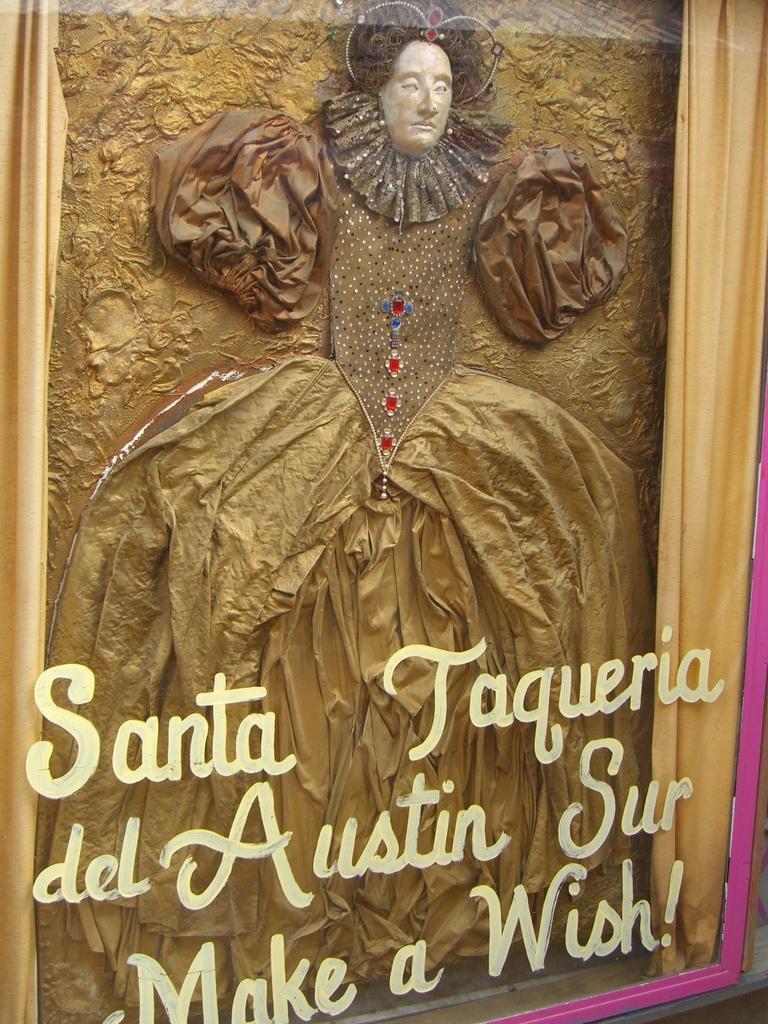Can you describe this image briefly? In this picture we can see a cloth, sculpture and the glass with some text on it. 